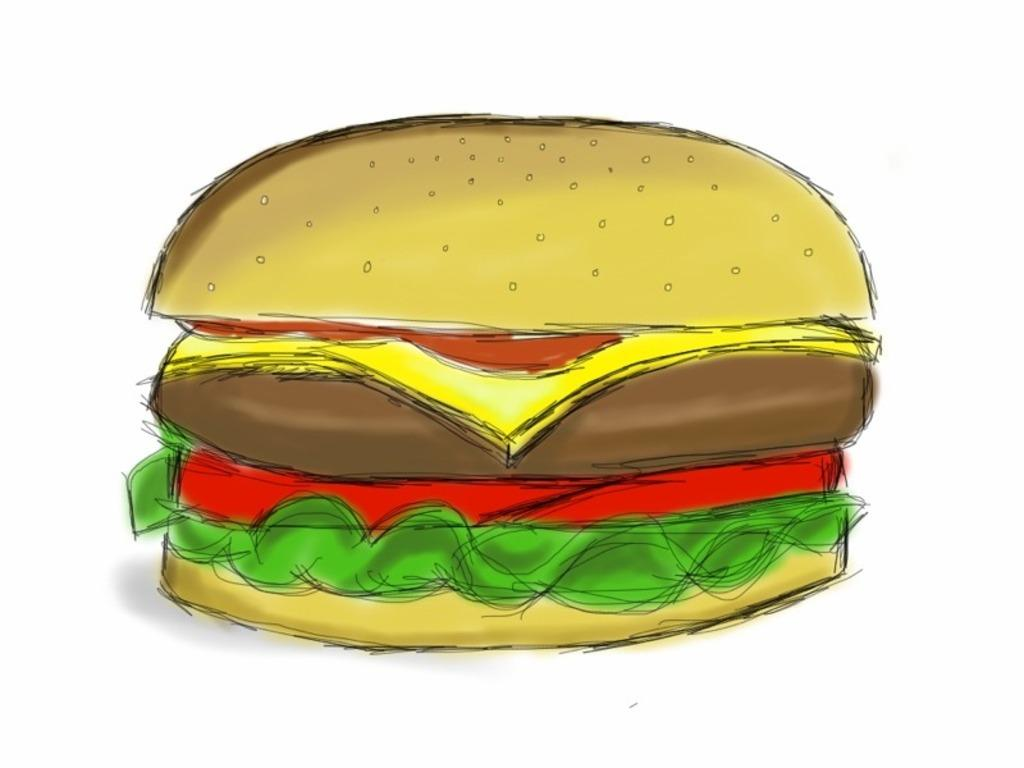What is the main subject of the image? The main subject of the image is a sketch of a burger. What color is the background of the image? The background of the image is white. Can you see a sponge soaking up water in the image? There is no sponge or water present in the image; it features a sketch of a burger on a white background. How many ants are crawling on the burger in the image? There are no ants present in the image; it features a sketch of a burger on a white background. 